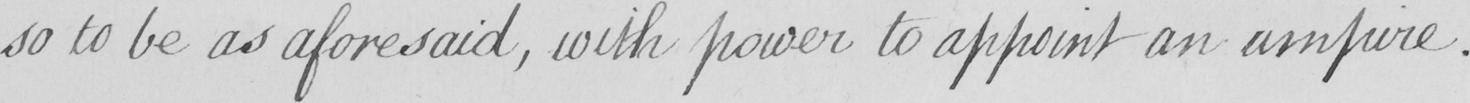Can you tell me what this handwritten text says? so to be as aforesaid  , with power to appoint an umpire . 